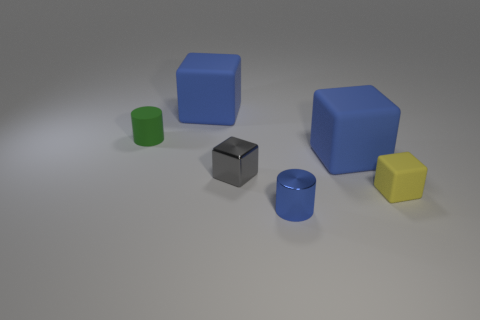What number of rubber things are the same size as the shiny cylinder?
Offer a terse response. 2. There is another tiny thing that is the same shape as the tiny green object; what is it made of?
Provide a succinct answer. Metal. How many things are tiny cylinders that are in front of the yellow thing or matte objects on the right side of the metallic cylinder?
Your answer should be compact. 3. Does the small green thing have the same shape as the shiny thing in front of the gray shiny cube?
Your response must be concise. Yes. There is a blue thing that is to the right of the cylinder that is in front of the cylinder to the left of the shiny cylinder; what is its shape?
Your response must be concise. Cube. What number of other objects are there of the same material as the small yellow cube?
Offer a terse response. 3. What number of things are either big blue blocks that are behind the green cylinder or green matte cylinders?
Give a very brief answer. 2. What is the shape of the shiny object in front of the tiny block that is behind the tiny yellow cube?
Make the answer very short. Cylinder. Is the shape of the blue matte thing that is to the right of the tiny blue object the same as  the tiny gray metallic thing?
Give a very brief answer. Yes. The rubber cube behind the green object is what color?
Your response must be concise. Blue. 